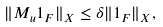Convert formula to latex. <formula><loc_0><loc_0><loc_500><loc_500>\| M _ { u } 1 _ { F } \| _ { X } \leq \delta \| 1 _ { F } \| _ { X } ,</formula> 